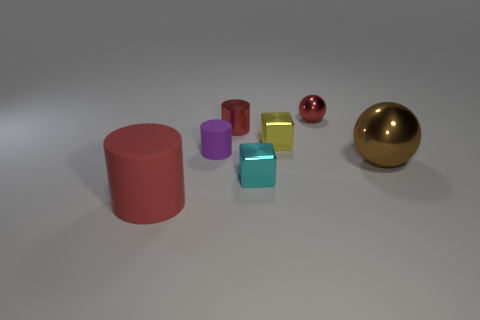Are any tiny red cylinders visible?
Give a very brief answer. Yes. Is the material of the tiny red sphere the same as the sphere that is to the right of the red shiny sphere?
Provide a succinct answer. Yes. There is a cube that is the same size as the yellow metallic thing; what is its material?
Make the answer very short. Metal. Are there any other objects made of the same material as the small purple object?
Your response must be concise. Yes. Are there any tiny purple cylinders that are behind the tiny cube that is behind the metal object that is right of the red sphere?
Offer a terse response. No. What is the shape of the purple object that is the same size as the cyan shiny cube?
Provide a short and direct response. Cylinder. Does the rubber object that is behind the large matte cylinder have the same size as the block that is behind the cyan block?
Offer a very short reply. Yes. How many big blue rubber objects are there?
Provide a succinct answer. 0. What size is the block that is on the right side of the cube in front of the matte object that is to the right of the large rubber thing?
Your answer should be very brief. Small. Does the large metal thing have the same color as the metallic cylinder?
Keep it short and to the point. No. 